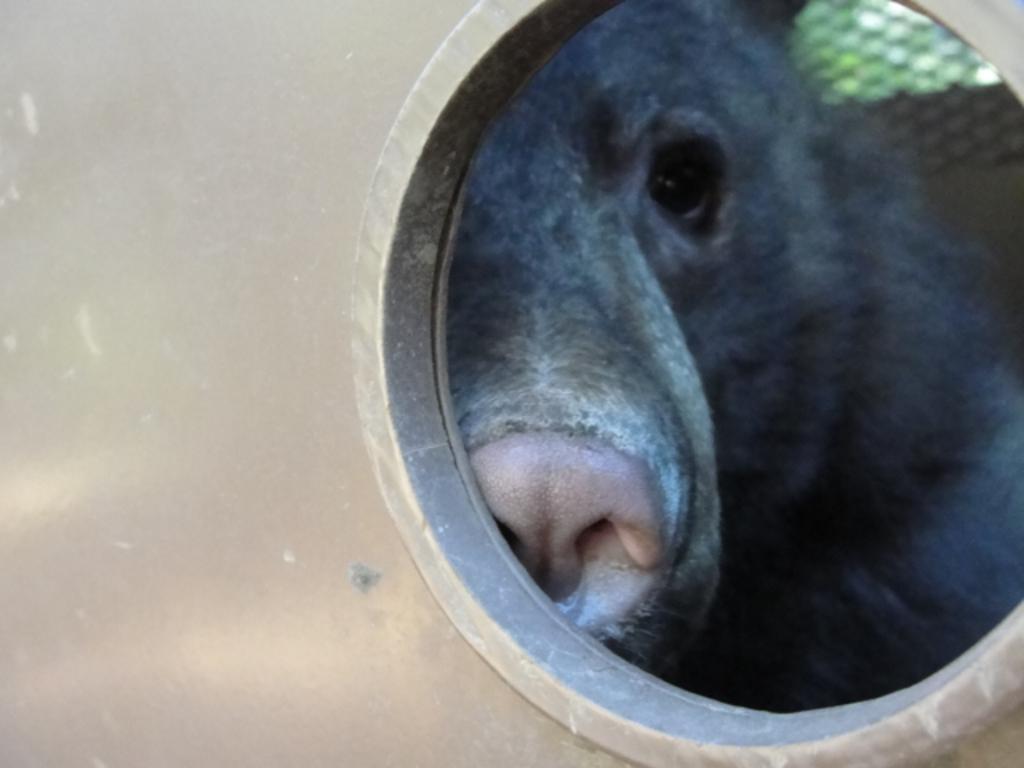Could you give a brief overview of what you see in this image? In this image there is a metal structure and a whole in it, from the whole we can see there is an animal. 